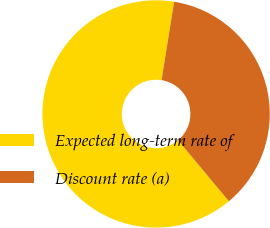Convert chart to OTSL. <chart><loc_0><loc_0><loc_500><loc_500><pie_chart><fcel>Expected long-term rate of<fcel>Discount rate (a)<nl><fcel>63.6%<fcel>36.4%<nl></chart> 